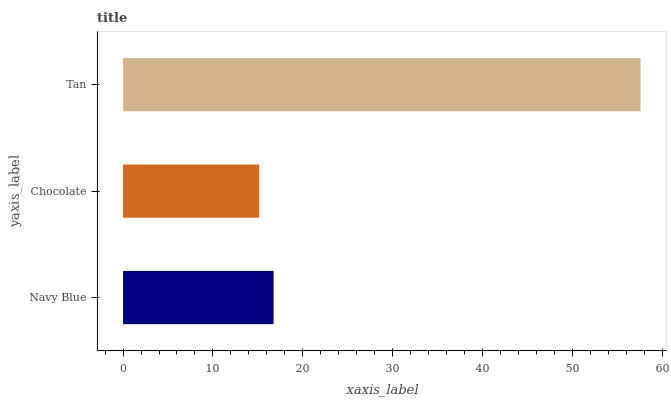Is Chocolate the minimum?
Answer yes or no. Yes. Is Tan the maximum?
Answer yes or no. Yes. Is Tan the minimum?
Answer yes or no. No. Is Chocolate the maximum?
Answer yes or no. No. Is Tan greater than Chocolate?
Answer yes or no. Yes. Is Chocolate less than Tan?
Answer yes or no. Yes. Is Chocolate greater than Tan?
Answer yes or no. No. Is Tan less than Chocolate?
Answer yes or no. No. Is Navy Blue the high median?
Answer yes or no. Yes. Is Navy Blue the low median?
Answer yes or no. Yes. Is Chocolate the high median?
Answer yes or no. No. Is Tan the low median?
Answer yes or no. No. 